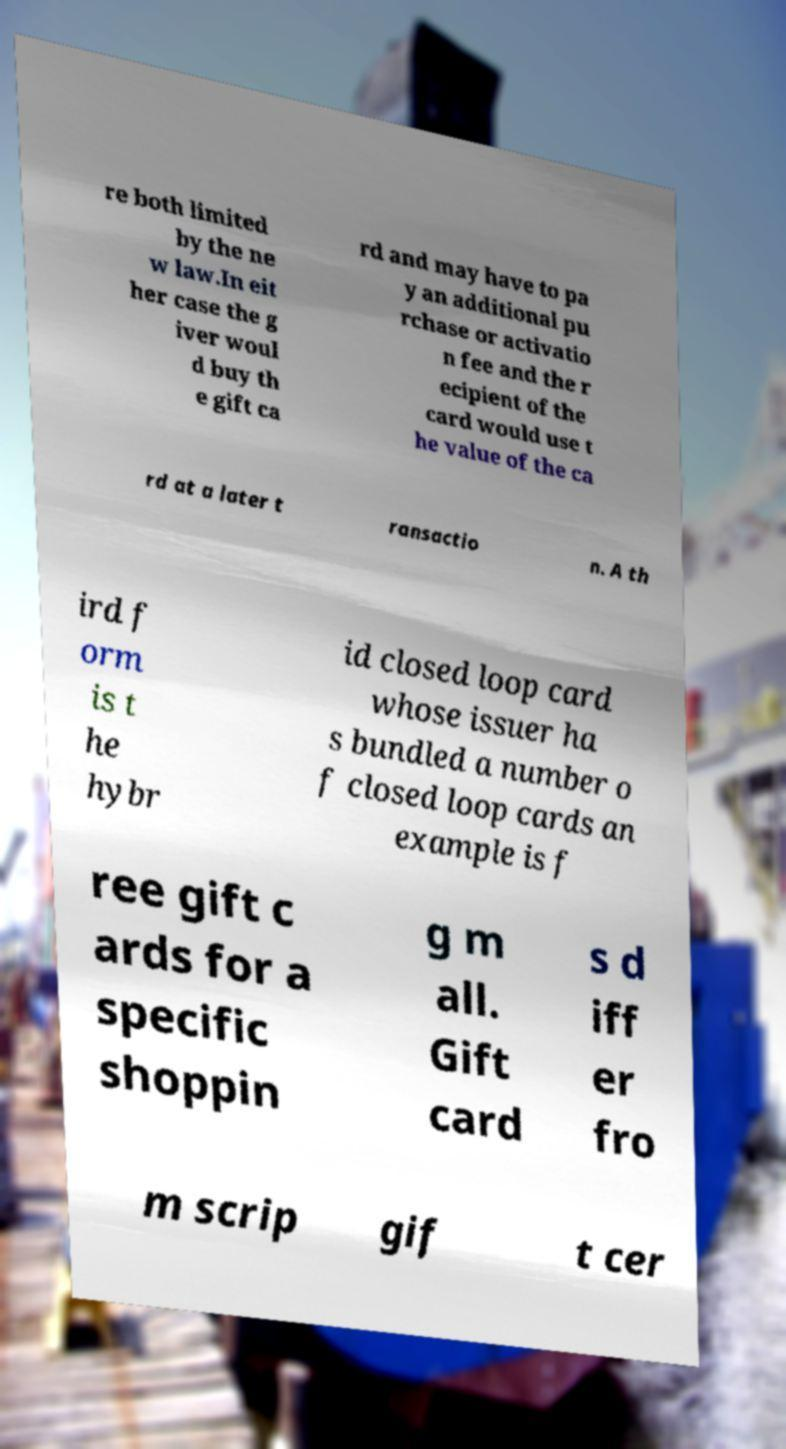Can you read and provide the text displayed in the image?This photo seems to have some interesting text. Can you extract and type it out for me? re both limited by the ne w law.In eit her case the g iver woul d buy th e gift ca rd and may have to pa y an additional pu rchase or activatio n fee and the r ecipient of the card would use t he value of the ca rd at a later t ransactio n. A th ird f orm is t he hybr id closed loop card whose issuer ha s bundled a number o f closed loop cards an example is f ree gift c ards for a specific shoppin g m all. Gift card s d iff er fro m scrip gif t cer 